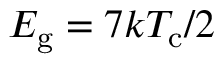<formula> <loc_0><loc_0><loc_500><loc_500>E _ { g } = 7 k T _ { c } / 2</formula> 